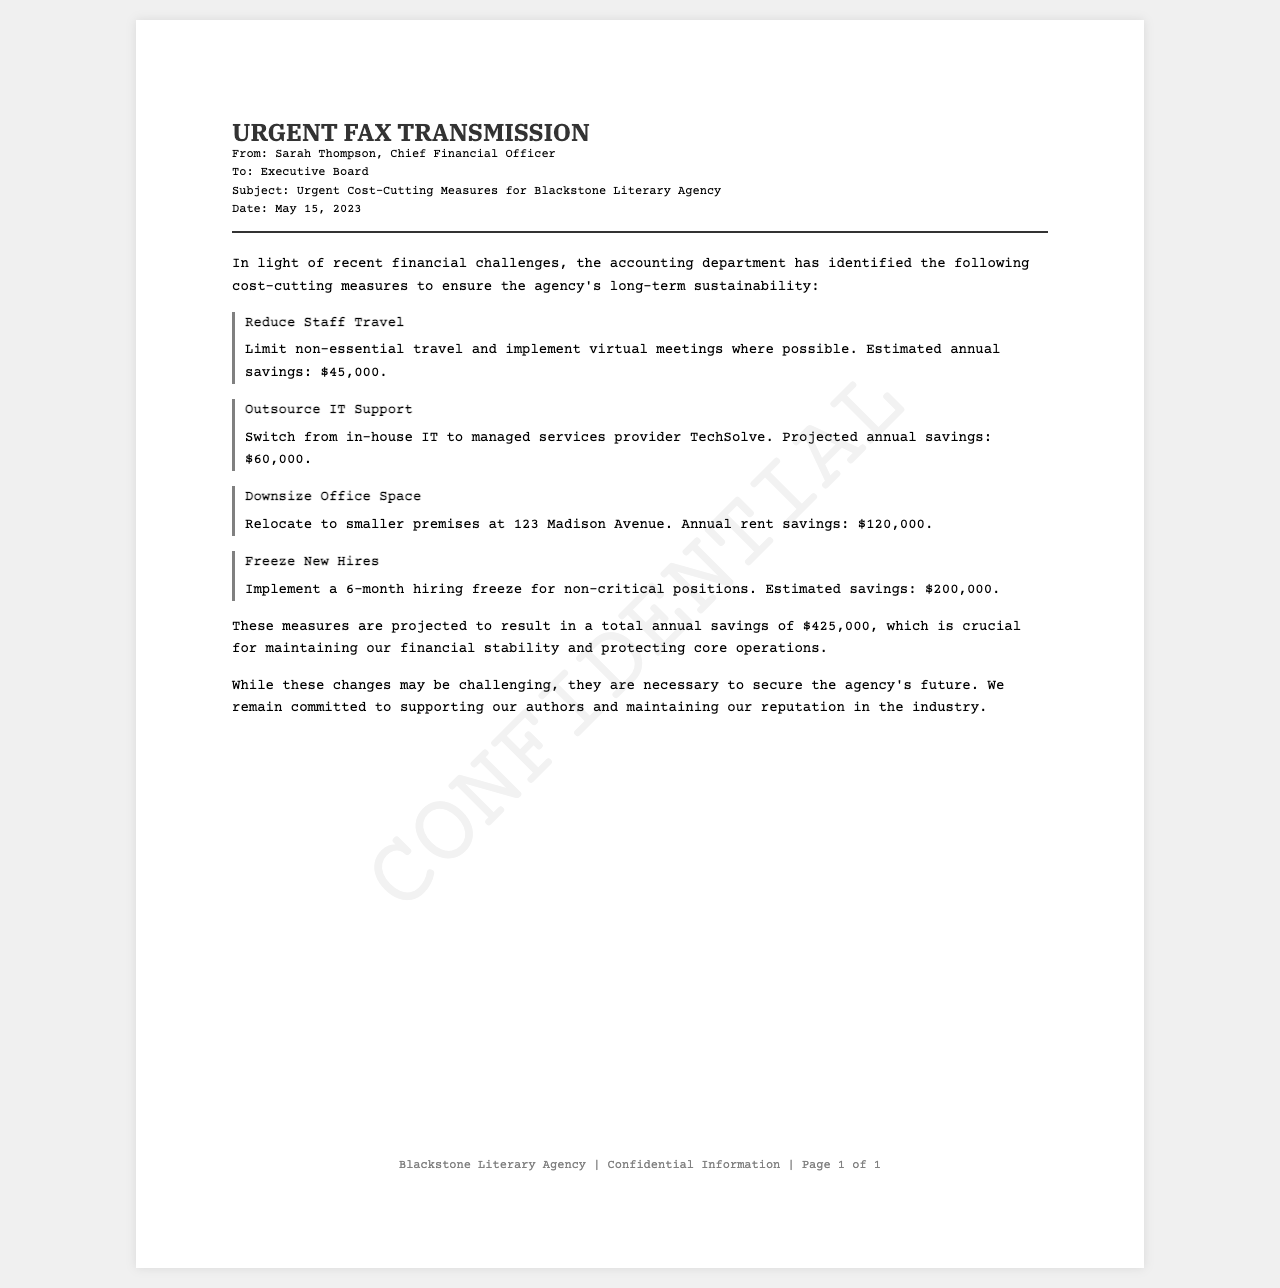What is the date of the memo? The date of the memo is clearly stated at the top of the document.
Answer: May 15, 2023 Who is the sender of the fax? The sender is mentioned in the fax header section of the document.
Answer: Sarah Thompson What is the estimated annual savings from outsourcing IT support? The estimated annual savings is provided for this specific cost-cutting measure.
Answer: $60,000 What is the total projected annual savings from all measures? The total savings is summarized towards the end of the document.
Answer: $425,000 What measure involves limiting non-essential travel? This specific measure is described in the context of cost-cutting strategies.
Answer: Reduce Staff Travel Why is a hiring freeze being implemented? The reason is inferred from the need for financial stability and is related to the document's overall purpose.
Answer: Financial stability What is the new address for the smaller office space? The new address for the downsized office is mentioned directly in the document.
Answer: 123 Madison Avenue What is the reason for the cost-cutting measures? The reason is explicitly stated in the introductory paragraph of the document.
Answer: Financial challenges How long is the hiring freeze planned for? The duration of the hiring freeze is specifically mentioned in one of the listed measures.
Answer: 6 months What type of document is this? The structure and content indicate this document serves a specific communication purpose within the organization.
Answer: Fax 